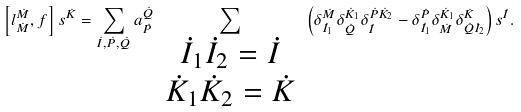Convert formula to latex. <formula><loc_0><loc_0><loc_500><loc_500>\left [ l ^ { \dot { M } } _ { \dot { M } } , f \right ] s ^ { \dot { K } } = \sum _ { \dot { I } , \dot { P } , \dot { Q } } a ^ { \dot { Q } } _ { \dot { P } } \sum _ { \begin{array} { c } \dot { I } _ { 1 } \dot { I } _ { 2 } = \dot { I } \\ \dot { K } _ { 1 } \dot { K } _ { 2 } = \dot { K } \end{array} } \left ( \delta ^ { \dot { M } } _ { \dot { I } _ { 1 } } \delta ^ { \dot { K } _ { 1 } } _ { \dot { Q } } \delta ^ { \dot { P } \dot { K } _ { 2 } } _ { \dot { I } } - \delta ^ { \dot { P } } _ { \dot { I } _ { 1 } } \delta ^ { \dot { K } _ { 1 } } _ { \dot { M } } \delta ^ { \dot { K } } _ { \dot { Q } \dot { I } _ { 2 } } \right ) s ^ { \dot { I } } .</formula> 